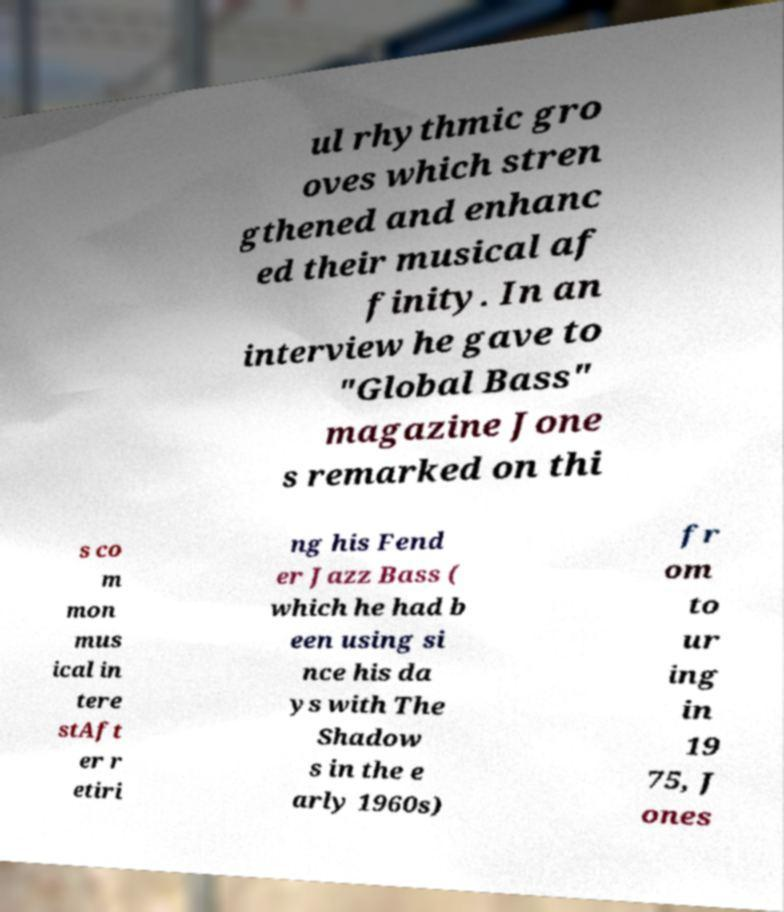I need the written content from this picture converted into text. Can you do that? ul rhythmic gro oves which stren gthened and enhanc ed their musical af finity. In an interview he gave to "Global Bass" magazine Jone s remarked on thi s co m mon mus ical in tere stAft er r etiri ng his Fend er Jazz Bass ( which he had b een using si nce his da ys with The Shadow s in the e arly 1960s) fr om to ur ing in 19 75, J ones 